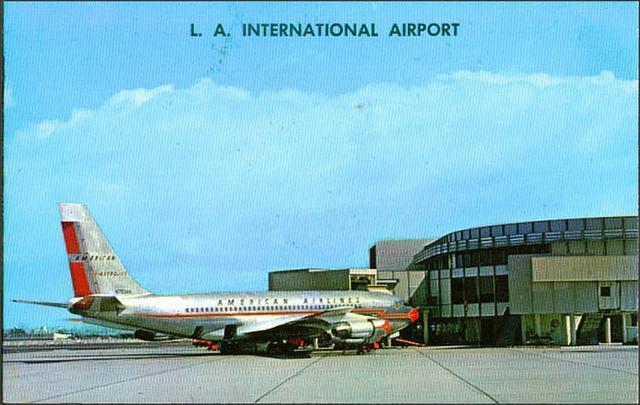How many black skateboards are in the image?
Give a very brief answer. 0. 